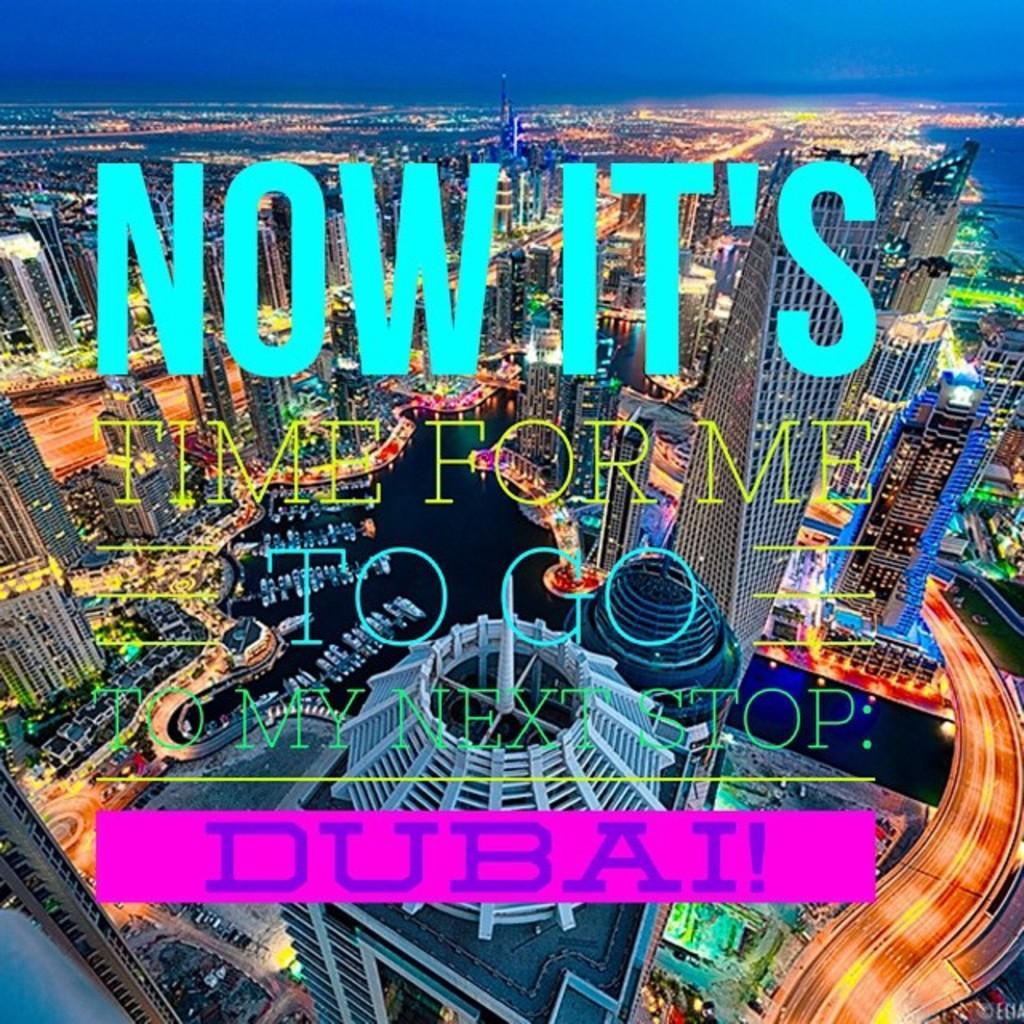Describe this image in one or two sentences. In this picture we can see some text, buildings, lights, bridgewater, some objects and in the background we can see the sky. 